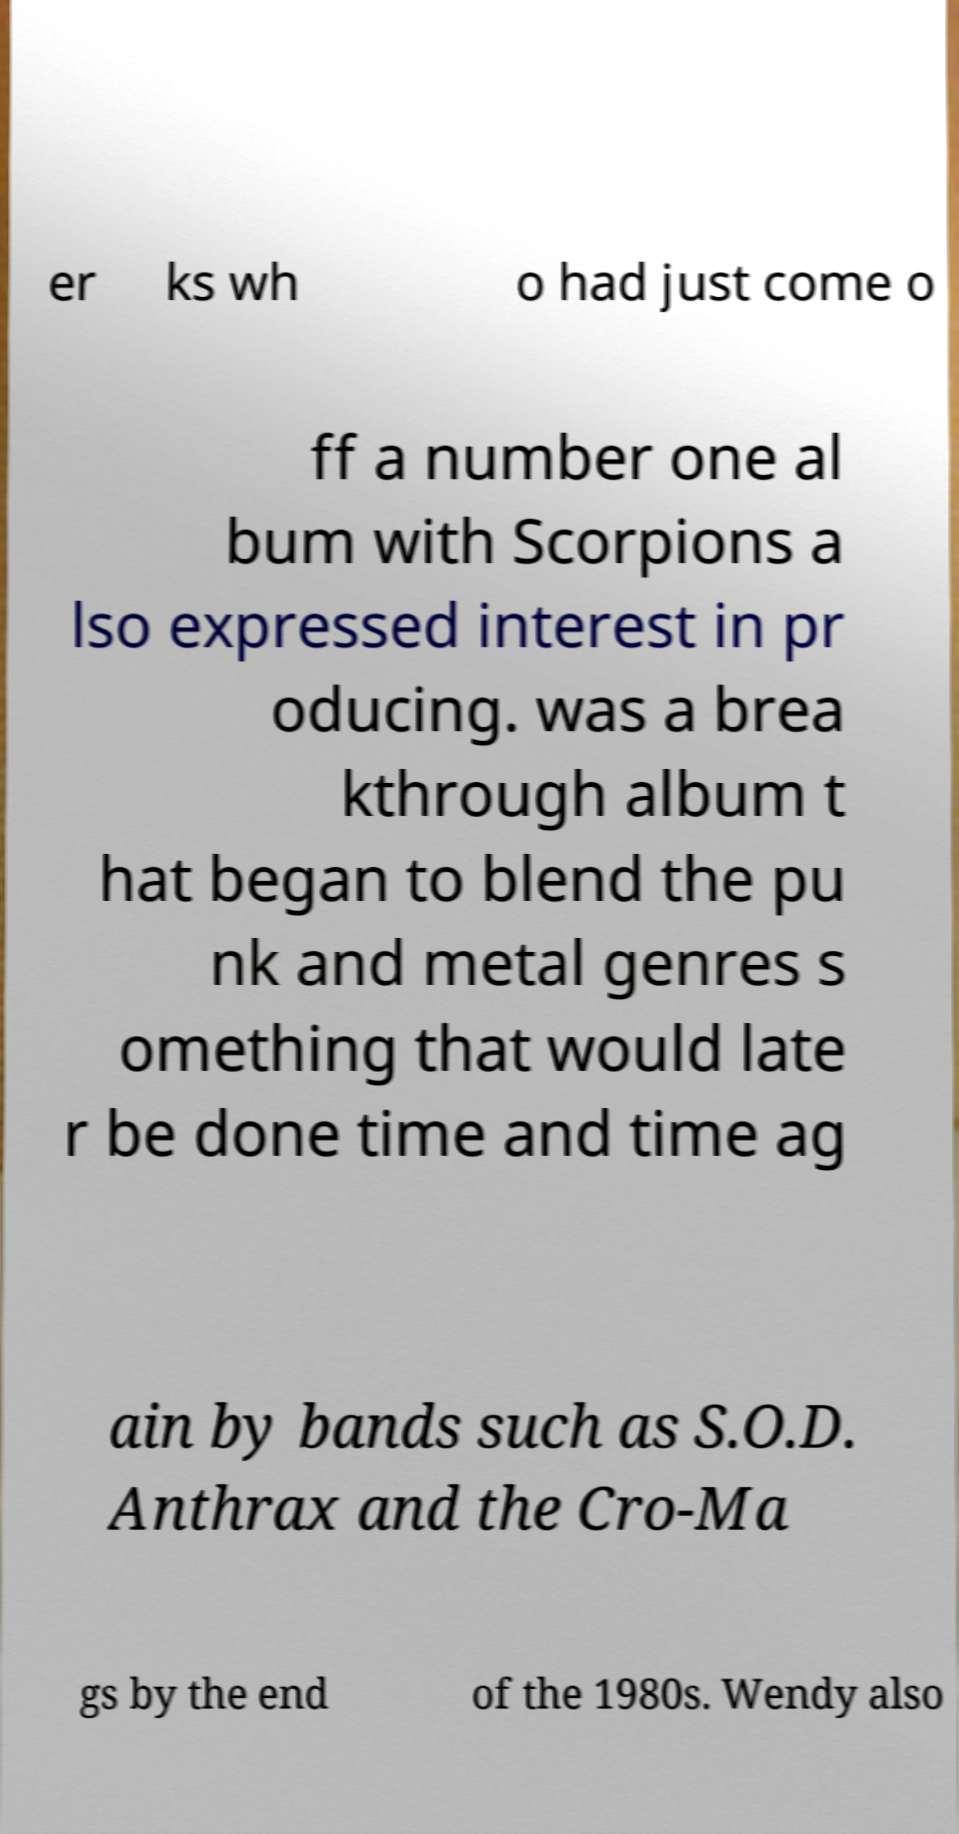Could you assist in decoding the text presented in this image and type it out clearly? er ks wh o had just come o ff a number one al bum with Scorpions a lso expressed interest in pr oducing. was a brea kthrough album t hat began to blend the pu nk and metal genres s omething that would late r be done time and time ag ain by bands such as S.O.D. Anthrax and the Cro-Ma gs by the end of the 1980s. Wendy also 